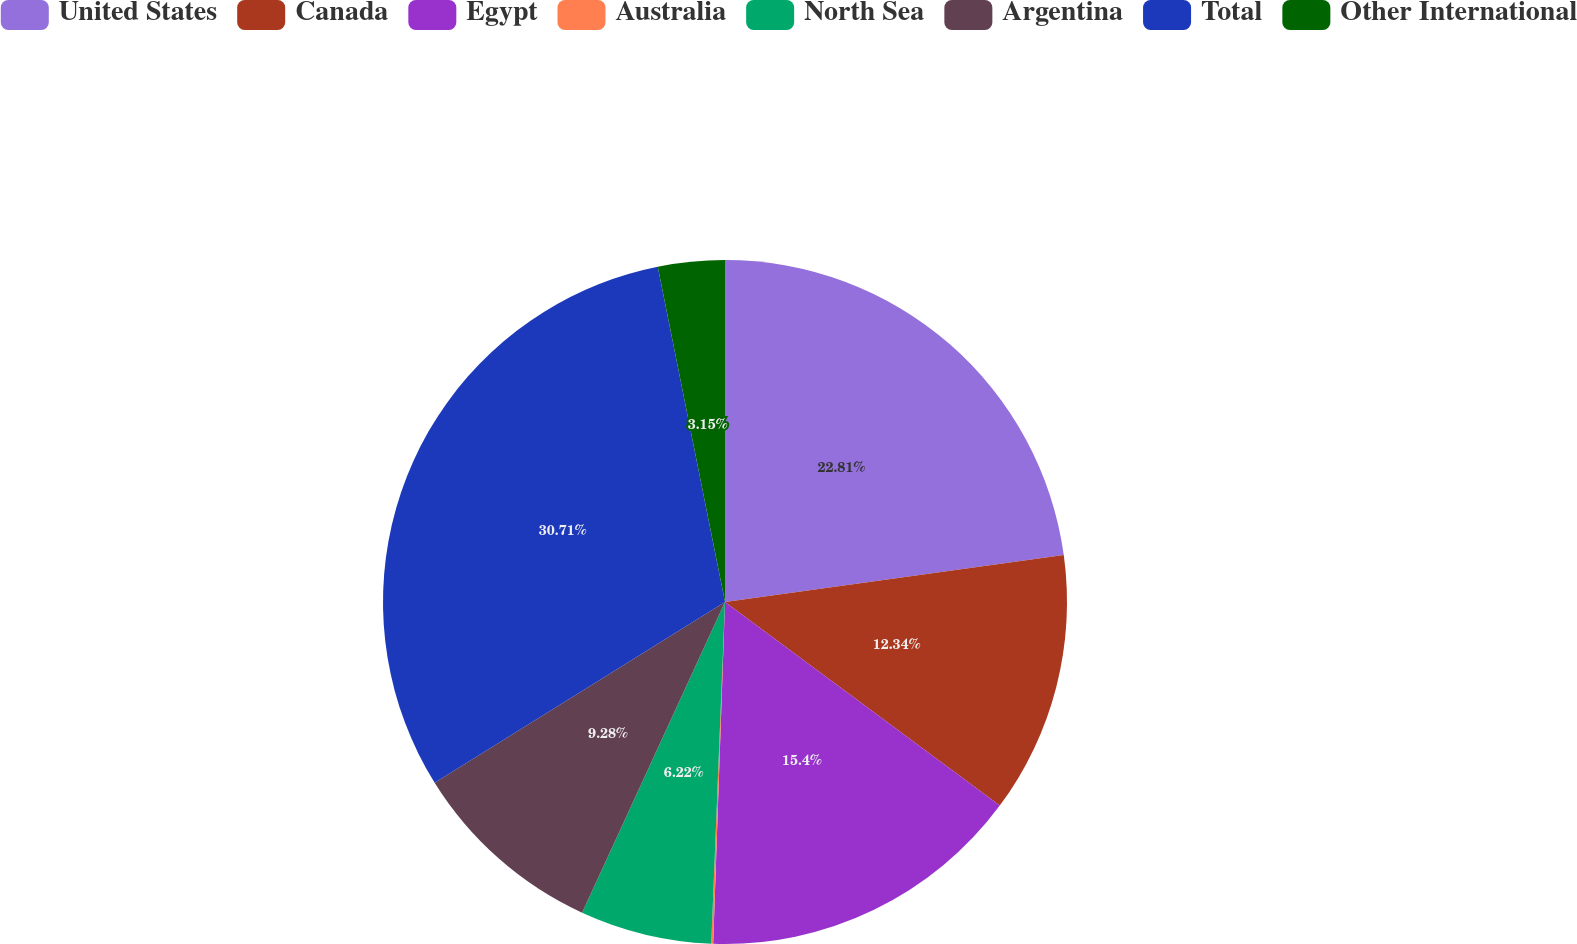Convert chart. <chart><loc_0><loc_0><loc_500><loc_500><pie_chart><fcel>United States<fcel>Canada<fcel>Egypt<fcel>Australia<fcel>North Sea<fcel>Argentina<fcel>Total<fcel>Other International<nl><fcel>22.81%<fcel>12.34%<fcel>15.4%<fcel>0.09%<fcel>6.22%<fcel>9.28%<fcel>30.71%<fcel>3.15%<nl></chart> 